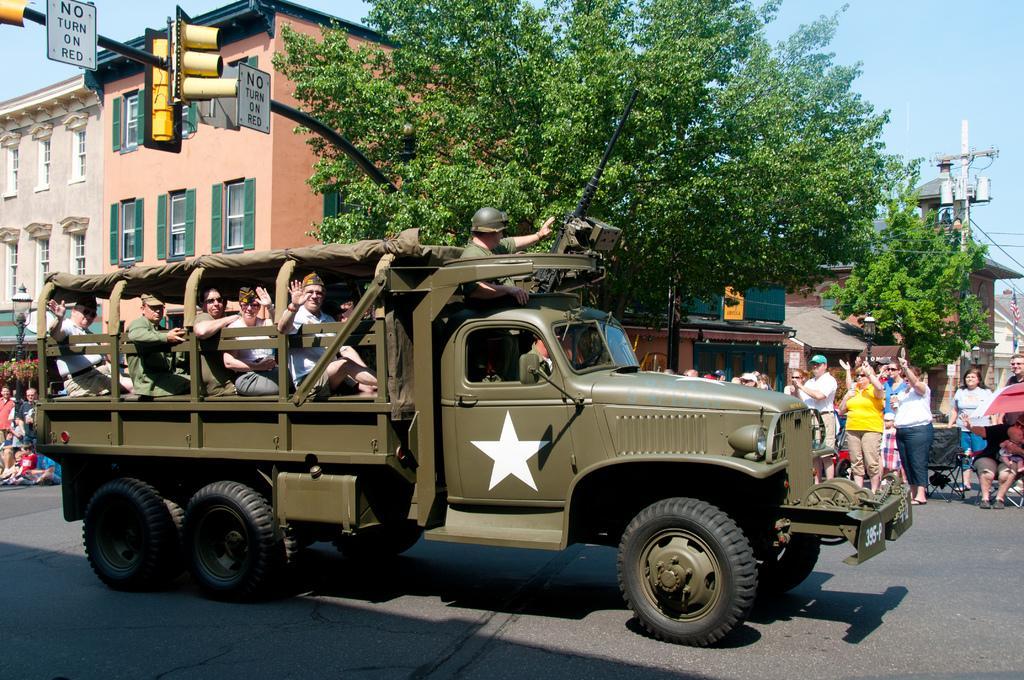Could you give a brief overview of what you see in this image? In this picture we can observe a vehicle. There are some members sitting in this vehicle. There is a gun on the top of this vehicle. We can observe a road. There are some people standing and watching this vehicle. We can observe traffic signals fixed to this pole on the left side. There are some trees and buildings here. In the background there is a sky. 